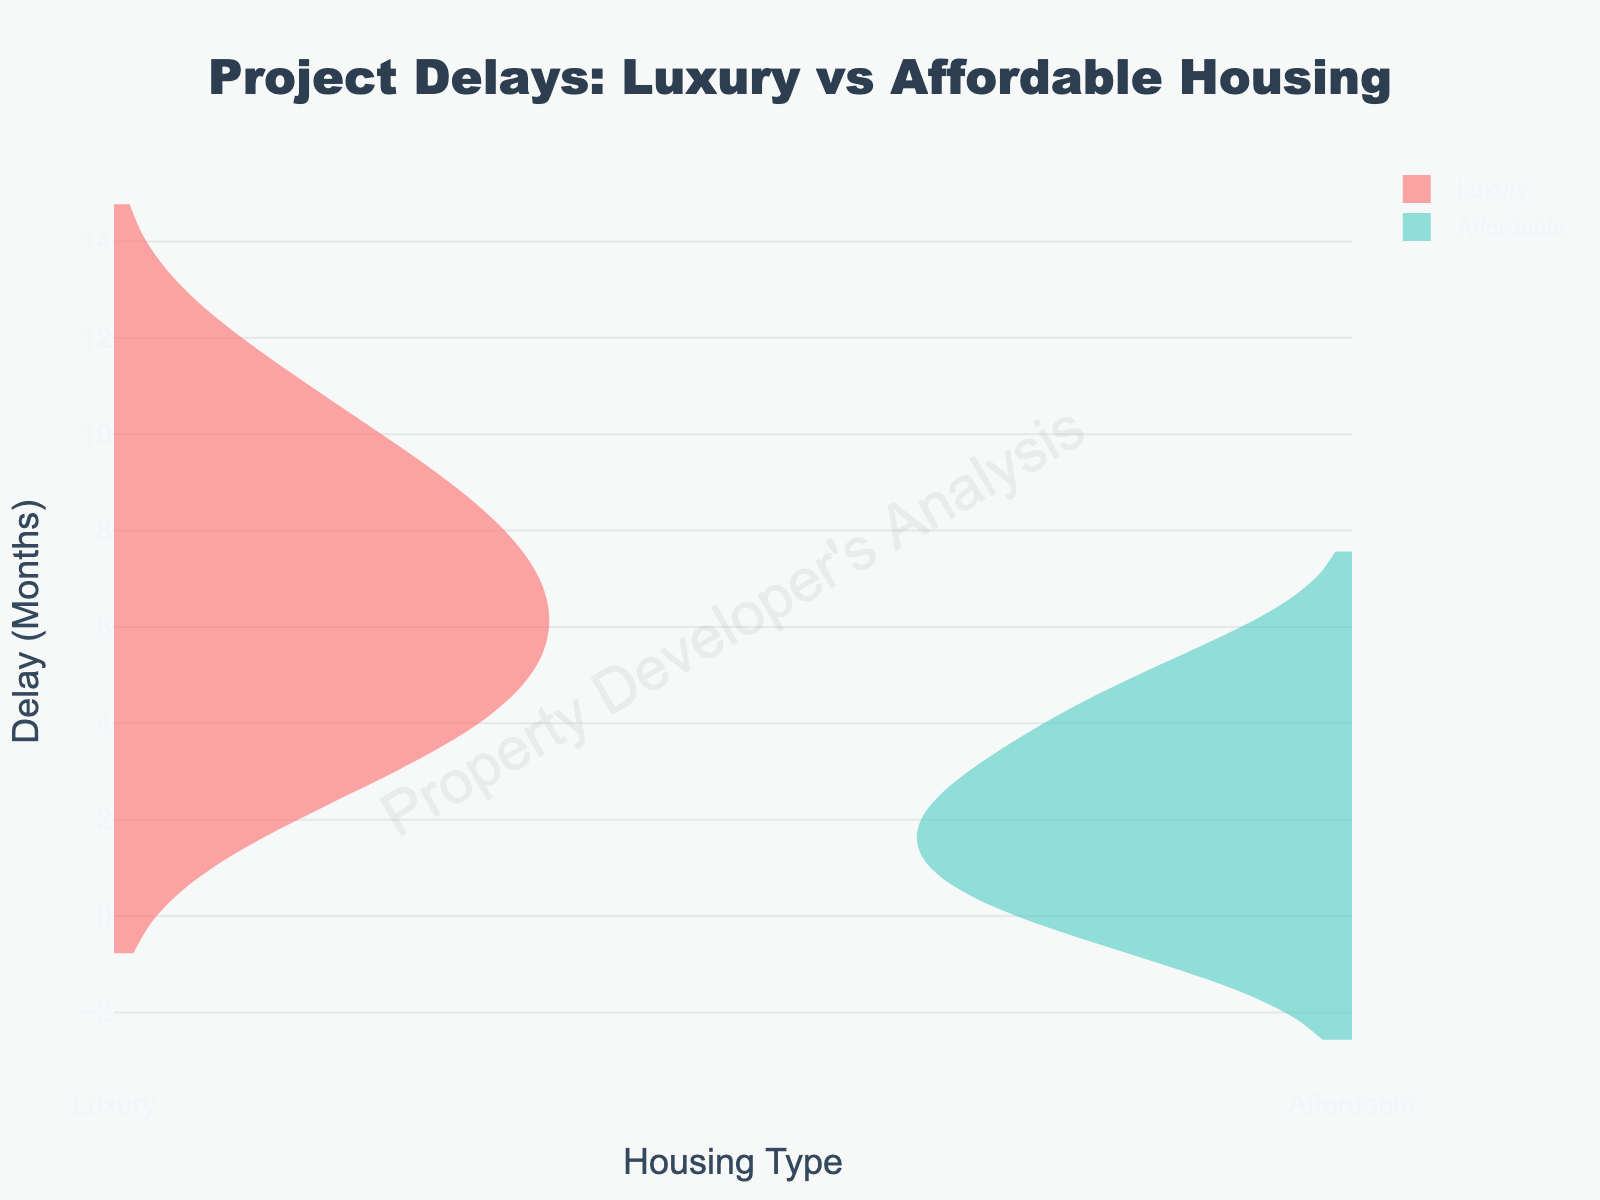What is the title of the chart? The title of the chart is located at the top center of the figure and reads "Project Delays: Luxury vs Affordable Housing".
Answer: Project Delays: Luxury vs Affordable Housing What are the housing types shown in the chart? The x-axis of the chart denotes the housing types depicted as "Luxury" and "Affordable".
Answer: Luxury and Affordable Which housing type shows a greater range of delays? By observing the lengths of the two violins, the "Luxury" housing type spans from 3 to 11 months, while the "Affordable" housing type spans from 0 to 5 months. Therefore, the range of delays is greater for "Luxury" housing.
Answer: Luxury How many projects have a delay of 0 months in "Affordable" housing? In the "Affordable" housing section of the violin chart, the small widening at 0 months indicates there are two projects with no delay, as this is where the violin is widest.
Answer: 2 What is the color used to represent "Luxury" housing delays? The violin representing "Luxury" housing delays is filled with a light shade of red. This information can be extracted from the figure's color assignment and legend.
Answer: Light red Which housing type has the largest delay and what is the delay duration? By looking at the extreme values in each violin plot, the "Luxury" housing type has the largest delay represented by the topmost point, which is 11 months.
Answer: Luxury, 11 months How do the most common delay durations compare between "Luxury" and "Affordable" housing? The density peaks of the violins show that "Luxury" housing delays are frequently around 8 months, while "Affordable" housing delays are more commonly around 2 to 3 months.
Answer: Luxury: 8 months, Affordable: 2 to 3 months What are the median delay values for both "Luxury" and "Affordable" housing types? The median is the point that splits the violin into equal parts. For "Luxury" housing, this appears around the middle at approximately 6.5 months. For "Affordable" housing, it appears in the middle at around 2.5 months.
Answer: Luxury: 6.5 months, Affordable: 2.5 months How does the variability of completion delays compare between the two housing types? "Luxury" housing shows wider spread (more variability) from 3 to 11 months, while "Affordable" housing values are more tightly clustered between 0 and 5 months, indicating less variability.
Answer: Luxury has more variability Are there any housing types that consistently have lower delays? By comparing the two violin plots, it is evident that "Affordable" housing consistently showcases lower delays compared to "Luxury" housing, as the highest delay for affordable is still inside the lowest range of luxury.
Answer: Yes, Affordable 